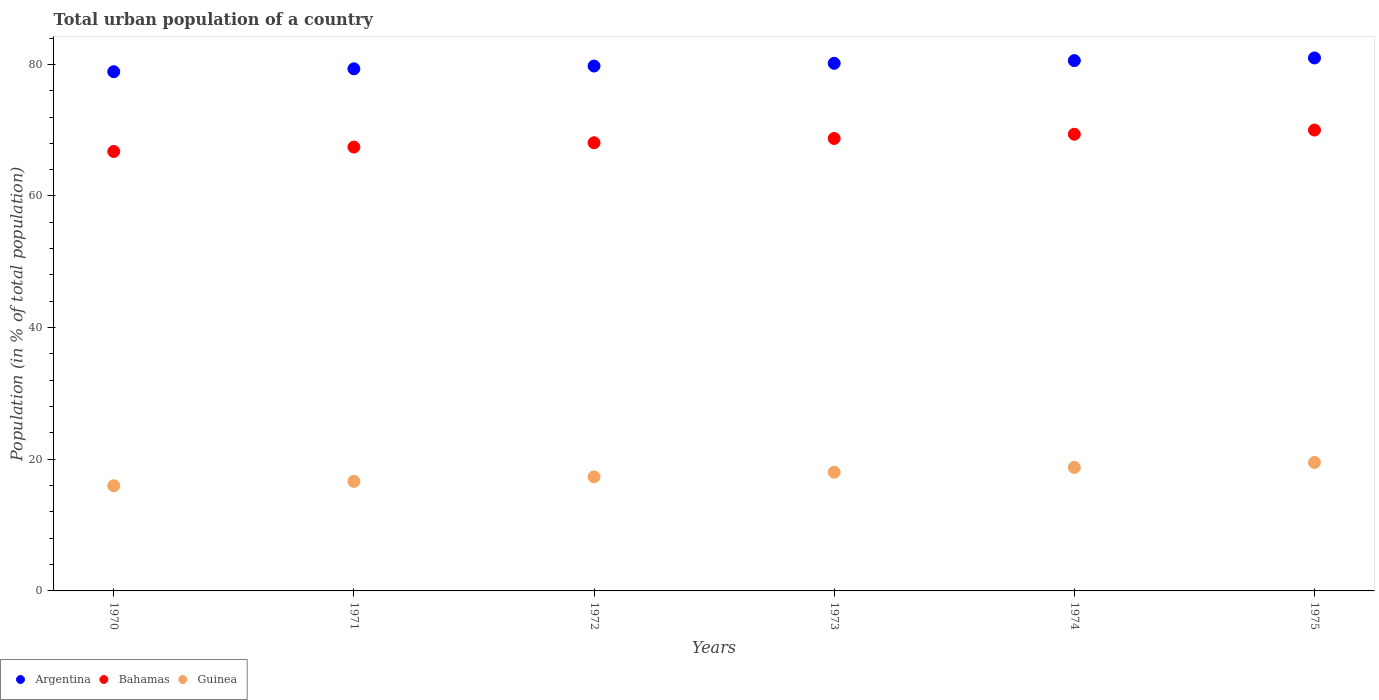Is the number of dotlines equal to the number of legend labels?
Offer a very short reply. Yes. What is the urban population in Argentina in 1972?
Give a very brief answer. 79.74. Across all years, what is the maximum urban population in Bahamas?
Your answer should be compact. 70.02. Across all years, what is the minimum urban population in Guinea?
Give a very brief answer. 15.98. In which year was the urban population in Argentina maximum?
Provide a short and direct response. 1975. In which year was the urban population in Bahamas minimum?
Your answer should be compact. 1970. What is the total urban population in Guinea in the graph?
Provide a short and direct response. 106.26. What is the difference between the urban population in Bahamas in 1970 and that in 1975?
Your answer should be very brief. -3.25. What is the difference between the urban population in Guinea in 1972 and the urban population in Bahamas in 1974?
Provide a succinct answer. -52.05. What is the average urban population in Bahamas per year?
Provide a succinct answer. 68.4. In the year 1970, what is the difference between the urban population in Guinea and urban population in Argentina?
Provide a short and direct response. -62.9. What is the ratio of the urban population in Guinea in 1970 to that in 1972?
Make the answer very short. 0.92. Is the difference between the urban population in Guinea in 1974 and 1975 greater than the difference between the urban population in Argentina in 1974 and 1975?
Provide a succinct answer. No. What is the difference between the highest and the second highest urban population in Argentina?
Ensure brevity in your answer.  0.4. What is the difference between the highest and the lowest urban population in Bahamas?
Your response must be concise. 3.25. Is the sum of the urban population in Guinea in 1972 and 1975 greater than the maximum urban population in Bahamas across all years?
Offer a terse response. No. Is the urban population in Bahamas strictly less than the urban population in Argentina over the years?
Offer a very short reply. Yes. What is the difference between two consecutive major ticks on the Y-axis?
Provide a short and direct response. 20. Does the graph contain any zero values?
Your answer should be compact. No. Where does the legend appear in the graph?
Make the answer very short. Bottom left. How many legend labels are there?
Provide a short and direct response. 3. How are the legend labels stacked?
Provide a succinct answer. Horizontal. What is the title of the graph?
Your answer should be compact. Total urban population of a country. What is the label or title of the Y-axis?
Your response must be concise. Population (in % of total population). What is the Population (in % of total population) of Argentina in 1970?
Keep it short and to the point. 78.88. What is the Population (in % of total population) of Bahamas in 1970?
Provide a short and direct response. 66.76. What is the Population (in % of total population) in Guinea in 1970?
Provide a short and direct response. 15.98. What is the Population (in % of total population) in Argentina in 1971?
Ensure brevity in your answer.  79.32. What is the Population (in % of total population) of Bahamas in 1971?
Make the answer very short. 67.43. What is the Population (in % of total population) in Guinea in 1971?
Give a very brief answer. 16.64. What is the Population (in % of total population) of Argentina in 1972?
Provide a succinct answer. 79.74. What is the Population (in % of total population) of Bahamas in 1972?
Your answer should be very brief. 68.09. What is the Population (in % of total population) of Guinea in 1972?
Your answer should be compact. 17.33. What is the Population (in % of total population) of Argentina in 1973?
Ensure brevity in your answer.  80.16. What is the Population (in % of total population) of Bahamas in 1973?
Your response must be concise. 68.74. What is the Population (in % of total population) of Guinea in 1973?
Keep it short and to the point. 18.03. What is the Population (in % of total population) of Argentina in 1974?
Your response must be concise. 80.57. What is the Population (in % of total population) of Bahamas in 1974?
Keep it short and to the point. 69.38. What is the Population (in % of total population) in Guinea in 1974?
Your answer should be compact. 18.76. What is the Population (in % of total population) of Argentina in 1975?
Give a very brief answer. 80.97. What is the Population (in % of total population) in Bahamas in 1975?
Your answer should be very brief. 70.02. What is the Population (in % of total population) in Guinea in 1975?
Give a very brief answer. 19.52. Across all years, what is the maximum Population (in % of total population) of Argentina?
Ensure brevity in your answer.  80.97. Across all years, what is the maximum Population (in % of total population) of Bahamas?
Give a very brief answer. 70.02. Across all years, what is the maximum Population (in % of total population) of Guinea?
Provide a succinct answer. 19.52. Across all years, what is the minimum Population (in % of total population) of Argentina?
Your response must be concise. 78.88. Across all years, what is the minimum Population (in % of total population) in Bahamas?
Offer a terse response. 66.76. Across all years, what is the minimum Population (in % of total population) in Guinea?
Make the answer very short. 15.98. What is the total Population (in % of total population) in Argentina in the graph?
Offer a terse response. 479.64. What is the total Population (in % of total population) in Bahamas in the graph?
Provide a short and direct response. 410.42. What is the total Population (in % of total population) in Guinea in the graph?
Offer a terse response. 106.26. What is the difference between the Population (in % of total population) of Argentina in 1970 and that in 1971?
Offer a terse response. -0.44. What is the difference between the Population (in % of total population) of Bahamas in 1970 and that in 1971?
Offer a terse response. -0.67. What is the difference between the Population (in % of total population) in Guinea in 1970 and that in 1971?
Ensure brevity in your answer.  -0.66. What is the difference between the Population (in % of total population) in Argentina in 1970 and that in 1972?
Ensure brevity in your answer.  -0.86. What is the difference between the Population (in % of total population) in Bahamas in 1970 and that in 1972?
Offer a very short reply. -1.32. What is the difference between the Population (in % of total population) of Guinea in 1970 and that in 1972?
Provide a succinct answer. -1.35. What is the difference between the Population (in % of total population) in Argentina in 1970 and that in 1973?
Offer a very short reply. -1.28. What is the difference between the Population (in % of total population) in Bahamas in 1970 and that in 1973?
Offer a very short reply. -1.97. What is the difference between the Population (in % of total population) of Guinea in 1970 and that in 1973?
Offer a very short reply. -2.06. What is the difference between the Population (in % of total population) in Argentina in 1970 and that in 1974?
Provide a succinct answer. -1.69. What is the difference between the Population (in % of total population) of Bahamas in 1970 and that in 1974?
Your answer should be compact. -2.62. What is the difference between the Population (in % of total population) in Guinea in 1970 and that in 1974?
Provide a succinct answer. -2.79. What is the difference between the Population (in % of total population) of Argentina in 1970 and that in 1975?
Keep it short and to the point. -2.09. What is the difference between the Population (in % of total population) of Bahamas in 1970 and that in 1975?
Provide a succinct answer. -3.25. What is the difference between the Population (in % of total population) of Guinea in 1970 and that in 1975?
Provide a short and direct response. -3.54. What is the difference between the Population (in % of total population) of Argentina in 1971 and that in 1972?
Provide a succinct answer. -0.42. What is the difference between the Population (in % of total population) of Bahamas in 1971 and that in 1972?
Offer a terse response. -0.66. What is the difference between the Population (in % of total population) of Guinea in 1971 and that in 1972?
Ensure brevity in your answer.  -0.69. What is the difference between the Population (in % of total population) of Argentina in 1971 and that in 1973?
Provide a short and direct response. -0.84. What is the difference between the Population (in % of total population) in Bahamas in 1971 and that in 1973?
Provide a succinct answer. -1.31. What is the difference between the Population (in % of total population) in Guinea in 1971 and that in 1973?
Provide a succinct answer. -1.39. What is the difference between the Population (in % of total population) in Argentina in 1971 and that in 1974?
Give a very brief answer. -1.25. What is the difference between the Population (in % of total population) of Bahamas in 1971 and that in 1974?
Offer a very short reply. -1.95. What is the difference between the Population (in % of total population) in Guinea in 1971 and that in 1974?
Offer a very short reply. -2.12. What is the difference between the Population (in % of total population) of Argentina in 1971 and that in 1975?
Your response must be concise. -1.65. What is the difference between the Population (in % of total population) of Bahamas in 1971 and that in 1975?
Offer a terse response. -2.59. What is the difference between the Population (in % of total population) of Guinea in 1971 and that in 1975?
Ensure brevity in your answer.  -2.87. What is the difference between the Population (in % of total population) in Argentina in 1972 and that in 1973?
Provide a short and direct response. -0.41. What is the difference between the Population (in % of total population) in Bahamas in 1972 and that in 1973?
Your answer should be compact. -0.65. What is the difference between the Population (in % of total population) of Guinea in 1972 and that in 1973?
Your response must be concise. -0.71. What is the difference between the Population (in % of total population) of Argentina in 1972 and that in 1974?
Your answer should be very brief. -0.82. What is the difference between the Population (in % of total population) of Bahamas in 1972 and that in 1974?
Your response must be concise. -1.29. What is the difference between the Population (in % of total population) of Guinea in 1972 and that in 1974?
Give a very brief answer. -1.44. What is the difference between the Population (in % of total population) of Argentina in 1972 and that in 1975?
Offer a very short reply. -1.23. What is the difference between the Population (in % of total population) in Bahamas in 1972 and that in 1975?
Offer a very short reply. -1.93. What is the difference between the Population (in % of total population) in Guinea in 1972 and that in 1975?
Keep it short and to the point. -2.19. What is the difference between the Population (in % of total population) of Argentina in 1973 and that in 1974?
Provide a short and direct response. -0.41. What is the difference between the Population (in % of total population) in Bahamas in 1973 and that in 1974?
Your answer should be compact. -0.64. What is the difference between the Population (in % of total population) of Guinea in 1973 and that in 1974?
Ensure brevity in your answer.  -0.73. What is the difference between the Population (in % of total population) in Argentina in 1973 and that in 1975?
Your response must be concise. -0.81. What is the difference between the Population (in % of total population) in Bahamas in 1973 and that in 1975?
Your answer should be very brief. -1.28. What is the difference between the Population (in % of total population) of Guinea in 1973 and that in 1975?
Offer a very short reply. -1.48. What is the difference between the Population (in % of total population) in Argentina in 1974 and that in 1975?
Your answer should be very brief. -0.4. What is the difference between the Population (in % of total population) of Bahamas in 1974 and that in 1975?
Offer a terse response. -0.64. What is the difference between the Population (in % of total population) of Guinea in 1974 and that in 1975?
Give a very brief answer. -0.75. What is the difference between the Population (in % of total population) in Argentina in 1970 and the Population (in % of total population) in Bahamas in 1971?
Give a very brief answer. 11.45. What is the difference between the Population (in % of total population) in Argentina in 1970 and the Population (in % of total population) in Guinea in 1971?
Provide a succinct answer. 62.24. What is the difference between the Population (in % of total population) in Bahamas in 1970 and the Population (in % of total population) in Guinea in 1971?
Offer a terse response. 50.12. What is the difference between the Population (in % of total population) of Argentina in 1970 and the Population (in % of total population) of Bahamas in 1972?
Your answer should be very brief. 10.79. What is the difference between the Population (in % of total population) in Argentina in 1970 and the Population (in % of total population) in Guinea in 1972?
Provide a succinct answer. 61.55. What is the difference between the Population (in % of total population) of Bahamas in 1970 and the Population (in % of total population) of Guinea in 1972?
Offer a very short reply. 49.44. What is the difference between the Population (in % of total population) in Argentina in 1970 and the Population (in % of total population) in Bahamas in 1973?
Offer a terse response. 10.14. What is the difference between the Population (in % of total population) of Argentina in 1970 and the Population (in % of total population) of Guinea in 1973?
Give a very brief answer. 60.85. What is the difference between the Population (in % of total population) of Bahamas in 1970 and the Population (in % of total population) of Guinea in 1973?
Your answer should be very brief. 48.73. What is the difference between the Population (in % of total population) in Argentina in 1970 and the Population (in % of total population) in Bahamas in 1974?
Ensure brevity in your answer.  9.5. What is the difference between the Population (in % of total population) of Argentina in 1970 and the Population (in % of total population) of Guinea in 1974?
Offer a very short reply. 60.12. What is the difference between the Population (in % of total population) of Bahamas in 1970 and the Population (in % of total population) of Guinea in 1974?
Make the answer very short. 48. What is the difference between the Population (in % of total population) of Argentina in 1970 and the Population (in % of total population) of Bahamas in 1975?
Ensure brevity in your answer.  8.86. What is the difference between the Population (in % of total population) of Argentina in 1970 and the Population (in % of total population) of Guinea in 1975?
Give a very brief answer. 59.37. What is the difference between the Population (in % of total population) in Bahamas in 1970 and the Population (in % of total population) in Guinea in 1975?
Offer a very short reply. 47.25. What is the difference between the Population (in % of total population) of Argentina in 1971 and the Population (in % of total population) of Bahamas in 1972?
Keep it short and to the point. 11.23. What is the difference between the Population (in % of total population) in Argentina in 1971 and the Population (in % of total population) in Guinea in 1972?
Offer a terse response. 61.99. What is the difference between the Population (in % of total population) of Bahamas in 1971 and the Population (in % of total population) of Guinea in 1972?
Your answer should be compact. 50.1. What is the difference between the Population (in % of total population) in Argentina in 1971 and the Population (in % of total population) in Bahamas in 1973?
Provide a succinct answer. 10.58. What is the difference between the Population (in % of total population) of Argentina in 1971 and the Population (in % of total population) of Guinea in 1973?
Keep it short and to the point. 61.29. What is the difference between the Population (in % of total population) in Bahamas in 1971 and the Population (in % of total population) in Guinea in 1973?
Make the answer very short. 49.4. What is the difference between the Population (in % of total population) of Argentina in 1971 and the Population (in % of total population) of Bahamas in 1974?
Give a very brief answer. 9.94. What is the difference between the Population (in % of total population) of Argentina in 1971 and the Population (in % of total population) of Guinea in 1974?
Provide a succinct answer. 60.56. What is the difference between the Population (in % of total population) of Bahamas in 1971 and the Population (in % of total population) of Guinea in 1974?
Offer a terse response. 48.67. What is the difference between the Population (in % of total population) of Argentina in 1971 and the Population (in % of total population) of Bahamas in 1975?
Give a very brief answer. 9.3. What is the difference between the Population (in % of total population) of Argentina in 1971 and the Population (in % of total population) of Guinea in 1975?
Ensure brevity in your answer.  59.81. What is the difference between the Population (in % of total population) of Bahamas in 1971 and the Population (in % of total population) of Guinea in 1975?
Offer a terse response. 47.91. What is the difference between the Population (in % of total population) of Argentina in 1972 and the Population (in % of total population) of Bahamas in 1973?
Provide a succinct answer. 11.01. What is the difference between the Population (in % of total population) of Argentina in 1972 and the Population (in % of total population) of Guinea in 1973?
Your answer should be very brief. 61.71. What is the difference between the Population (in % of total population) in Bahamas in 1972 and the Population (in % of total population) in Guinea in 1973?
Offer a very short reply. 50.05. What is the difference between the Population (in % of total population) of Argentina in 1972 and the Population (in % of total population) of Bahamas in 1974?
Provide a short and direct response. 10.36. What is the difference between the Population (in % of total population) of Argentina in 1972 and the Population (in % of total population) of Guinea in 1974?
Your response must be concise. 60.98. What is the difference between the Population (in % of total population) in Bahamas in 1972 and the Population (in % of total population) in Guinea in 1974?
Offer a very short reply. 49.33. What is the difference between the Population (in % of total population) in Argentina in 1972 and the Population (in % of total population) in Bahamas in 1975?
Your answer should be very brief. 9.73. What is the difference between the Population (in % of total population) in Argentina in 1972 and the Population (in % of total population) in Guinea in 1975?
Your response must be concise. 60.23. What is the difference between the Population (in % of total population) in Bahamas in 1972 and the Population (in % of total population) in Guinea in 1975?
Offer a terse response. 48.57. What is the difference between the Population (in % of total population) of Argentina in 1973 and the Population (in % of total population) of Bahamas in 1974?
Ensure brevity in your answer.  10.78. What is the difference between the Population (in % of total population) of Argentina in 1973 and the Population (in % of total population) of Guinea in 1974?
Ensure brevity in your answer.  61.4. What is the difference between the Population (in % of total population) in Bahamas in 1973 and the Population (in % of total population) in Guinea in 1974?
Give a very brief answer. 49.98. What is the difference between the Population (in % of total population) in Argentina in 1973 and the Population (in % of total population) in Bahamas in 1975?
Your answer should be very brief. 10.14. What is the difference between the Population (in % of total population) of Argentina in 1973 and the Population (in % of total population) of Guinea in 1975?
Your response must be concise. 60.64. What is the difference between the Population (in % of total population) in Bahamas in 1973 and the Population (in % of total population) in Guinea in 1975?
Offer a terse response. 49.22. What is the difference between the Population (in % of total population) of Argentina in 1974 and the Population (in % of total population) of Bahamas in 1975?
Ensure brevity in your answer.  10.55. What is the difference between the Population (in % of total population) in Argentina in 1974 and the Population (in % of total population) in Guinea in 1975?
Your response must be concise. 61.05. What is the difference between the Population (in % of total population) of Bahamas in 1974 and the Population (in % of total population) of Guinea in 1975?
Your answer should be very brief. 49.87. What is the average Population (in % of total population) in Argentina per year?
Offer a terse response. 79.94. What is the average Population (in % of total population) in Bahamas per year?
Offer a terse response. 68.4. What is the average Population (in % of total population) in Guinea per year?
Make the answer very short. 17.71. In the year 1970, what is the difference between the Population (in % of total population) of Argentina and Population (in % of total population) of Bahamas?
Your answer should be compact. 12.12. In the year 1970, what is the difference between the Population (in % of total population) in Argentina and Population (in % of total population) in Guinea?
Keep it short and to the point. 62.9. In the year 1970, what is the difference between the Population (in % of total population) in Bahamas and Population (in % of total population) in Guinea?
Keep it short and to the point. 50.79. In the year 1971, what is the difference between the Population (in % of total population) of Argentina and Population (in % of total population) of Bahamas?
Offer a terse response. 11.89. In the year 1971, what is the difference between the Population (in % of total population) in Argentina and Population (in % of total population) in Guinea?
Give a very brief answer. 62.68. In the year 1971, what is the difference between the Population (in % of total population) of Bahamas and Population (in % of total population) of Guinea?
Make the answer very short. 50.79. In the year 1972, what is the difference between the Population (in % of total population) in Argentina and Population (in % of total population) in Bahamas?
Keep it short and to the point. 11.65. In the year 1972, what is the difference between the Population (in % of total population) of Argentina and Population (in % of total population) of Guinea?
Offer a very short reply. 62.42. In the year 1972, what is the difference between the Population (in % of total population) in Bahamas and Population (in % of total population) in Guinea?
Your answer should be compact. 50.76. In the year 1973, what is the difference between the Population (in % of total population) in Argentina and Population (in % of total population) in Bahamas?
Your answer should be very brief. 11.42. In the year 1973, what is the difference between the Population (in % of total population) in Argentina and Population (in % of total population) in Guinea?
Keep it short and to the point. 62.12. In the year 1973, what is the difference between the Population (in % of total population) in Bahamas and Population (in % of total population) in Guinea?
Provide a short and direct response. 50.7. In the year 1974, what is the difference between the Population (in % of total population) of Argentina and Population (in % of total population) of Bahamas?
Keep it short and to the point. 11.19. In the year 1974, what is the difference between the Population (in % of total population) of Argentina and Population (in % of total population) of Guinea?
Your answer should be compact. 61.8. In the year 1974, what is the difference between the Population (in % of total population) in Bahamas and Population (in % of total population) in Guinea?
Your answer should be compact. 50.62. In the year 1975, what is the difference between the Population (in % of total population) in Argentina and Population (in % of total population) in Bahamas?
Give a very brief answer. 10.95. In the year 1975, what is the difference between the Population (in % of total population) in Argentina and Population (in % of total population) in Guinea?
Provide a short and direct response. 61.45. In the year 1975, what is the difference between the Population (in % of total population) in Bahamas and Population (in % of total population) in Guinea?
Offer a very short reply. 50.5. What is the ratio of the Population (in % of total population) of Argentina in 1970 to that in 1971?
Ensure brevity in your answer.  0.99. What is the ratio of the Population (in % of total population) of Guinea in 1970 to that in 1971?
Offer a very short reply. 0.96. What is the ratio of the Population (in % of total population) of Bahamas in 1970 to that in 1972?
Your answer should be compact. 0.98. What is the ratio of the Population (in % of total population) in Guinea in 1970 to that in 1972?
Ensure brevity in your answer.  0.92. What is the ratio of the Population (in % of total population) in Argentina in 1970 to that in 1973?
Offer a terse response. 0.98. What is the ratio of the Population (in % of total population) of Bahamas in 1970 to that in 1973?
Provide a succinct answer. 0.97. What is the ratio of the Population (in % of total population) in Guinea in 1970 to that in 1973?
Make the answer very short. 0.89. What is the ratio of the Population (in % of total population) of Argentina in 1970 to that in 1974?
Make the answer very short. 0.98. What is the ratio of the Population (in % of total population) in Bahamas in 1970 to that in 1974?
Ensure brevity in your answer.  0.96. What is the ratio of the Population (in % of total population) of Guinea in 1970 to that in 1974?
Provide a succinct answer. 0.85. What is the ratio of the Population (in % of total population) in Argentina in 1970 to that in 1975?
Keep it short and to the point. 0.97. What is the ratio of the Population (in % of total population) in Bahamas in 1970 to that in 1975?
Provide a succinct answer. 0.95. What is the ratio of the Population (in % of total population) of Guinea in 1970 to that in 1975?
Provide a succinct answer. 0.82. What is the ratio of the Population (in % of total population) of Argentina in 1971 to that in 1972?
Offer a terse response. 0.99. What is the ratio of the Population (in % of total population) of Bahamas in 1971 to that in 1972?
Offer a terse response. 0.99. What is the ratio of the Population (in % of total population) in Guinea in 1971 to that in 1972?
Your response must be concise. 0.96. What is the ratio of the Population (in % of total population) in Argentina in 1971 to that in 1973?
Offer a terse response. 0.99. What is the ratio of the Population (in % of total population) of Guinea in 1971 to that in 1973?
Make the answer very short. 0.92. What is the ratio of the Population (in % of total population) of Argentina in 1971 to that in 1974?
Offer a terse response. 0.98. What is the ratio of the Population (in % of total population) of Bahamas in 1971 to that in 1974?
Your answer should be compact. 0.97. What is the ratio of the Population (in % of total population) in Guinea in 1971 to that in 1974?
Provide a short and direct response. 0.89. What is the ratio of the Population (in % of total population) of Argentina in 1971 to that in 1975?
Your answer should be compact. 0.98. What is the ratio of the Population (in % of total population) in Guinea in 1971 to that in 1975?
Give a very brief answer. 0.85. What is the ratio of the Population (in % of total population) of Guinea in 1972 to that in 1973?
Keep it short and to the point. 0.96. What is the ratio of the Population (in % of total population) in Argentina in 1972 to that in 1974?
Your answer should be very brief. 0.99. What is the ratio of the Population (in % of total population) in Bahamas in 1972 to that in 1974?
Ensure brevity in your answer.  0.98. What is the ratio of the Population (in % of total population) in Guinea in 1972 to that in 1974?
Ensure brevity in your answer.  0.92. What is the ratio of the Population (in % of total population) in Argentina in 1972 to that in 1975?
Keep it short and to the point. 0.98. What is the ratio of the Population (in % of total population) of Bahamas in 1972 to that in 1975?
Your response must be concise. 0.97. What is the ratio of the Population (in % of total population) in Guinea in 1972 to that in 1975?
Offer a terse response. 0.89. What is the ratio of the Population (in % of total population) in Bahamas in 1973 to that in 1974?
Your response must be concise. 0.99. What is the ratio of the Population (in % of total population) of Guinea in 1973 to that in 1974?
Keep it short and to the point. 0.96. What is the ratio of the Population (in % of total population) of Bahamas in 1973 to that in 1975?
Your response must be concise. 0.98. What is the ratio of the Population (in % of total population) in Guinea in 1973 to that in 1975?
Your answer should be very brief. 0.92. What is the ratio of the Population (in % of total population) in Bahamas in 1974 to that in 1975?
Offer a very short reply. 0.99. What is the ratio of the Population (in % of total population) of Guinea in 1974 to that in 1975?
Your response must be concise. 0.96. What is the difference between the highest and the second highest Population (in % of total population) of Argentina?
Your answer should be very brief. 0.4. What is the difference between the highest and the second highest Population (in % of total population) of Bahamas?
Make the answer very short. 0.64. What is the difference between the highest and the second highest Population (in % of total population) in Guinea?
Offer a terse response. 0.75. What is the difference between the highest and the lowest Population (in % of total population) in Argentina?
Your response must be concise. 2.09. What is the difference between the highest and the lowest Population (in % of total population) of Bahamas?
Give a very brief answer. 3.25. What is the difference between the highest and the lowest Population (in % of total population) in Guinea?
Keep it short and to the point. 3.54. 